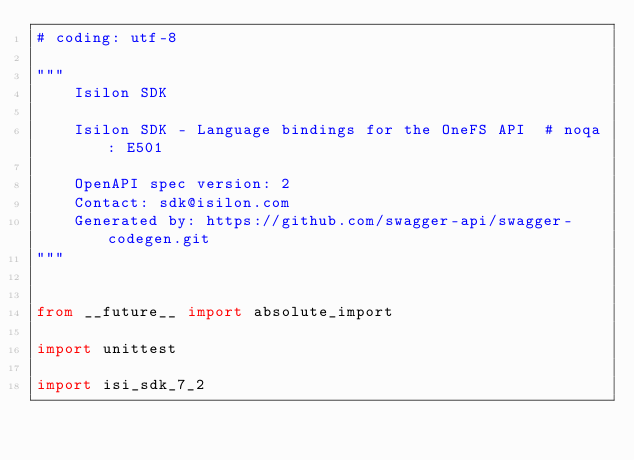Convert code to text. <code><loc_0><loc_0><loc_500><loc_500><_Python_># coding: utf-8

"""
    Isilon SDK

    Isilon SDK - Language bindings for the OneFS API  # noqa: E501

    OpenAPI spec version: 2
    Contact: sdk@isilon.com
    Generated by: https://github.com/swagger-api/swagger-codegen.git
"""


from __future__ import absolute_import

import unittest

import isi_sdk_7_2</code> 